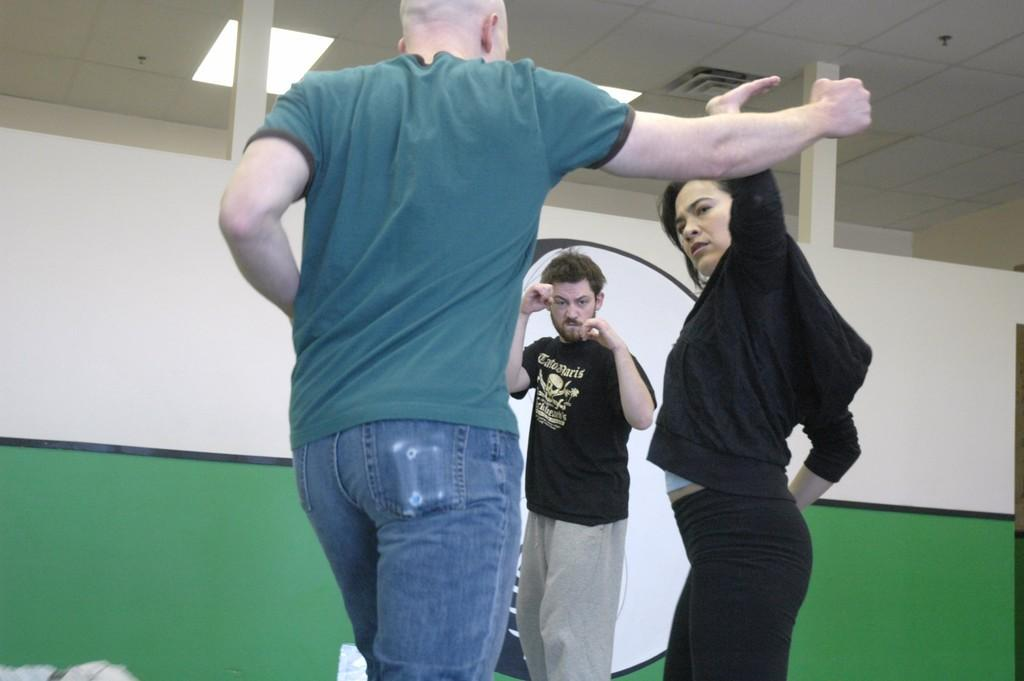How many people are in the image? There are three persons standing in the image. What is behind the persons in the image? There is a wall behind the persons. Can you describe any additional features in the image? There are lights attached to the roof in the top part of the image. What direction is the frog hopping in the image? There is no frog present in the image, so it cannot be determined which direction a frog might be hopping. 